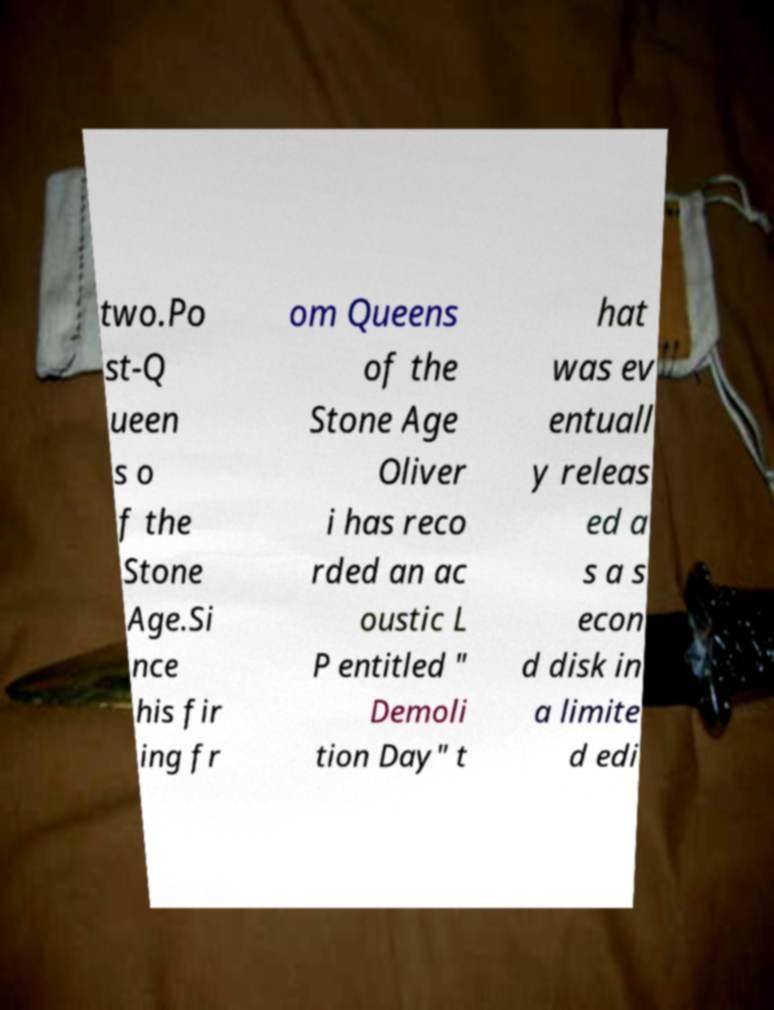Could you assist in decoding the text presented in this image and type it out clearly? two.Po st-Q ueen s o f the Stone Age.Si nce his fir ing fr om Queens of the Stone Age Oliver i has reco rded an ac oustic L P entitled " Demoli tion Day" t hat was ev entuall y releas ed a s a s econ d disk in a limite d edi 